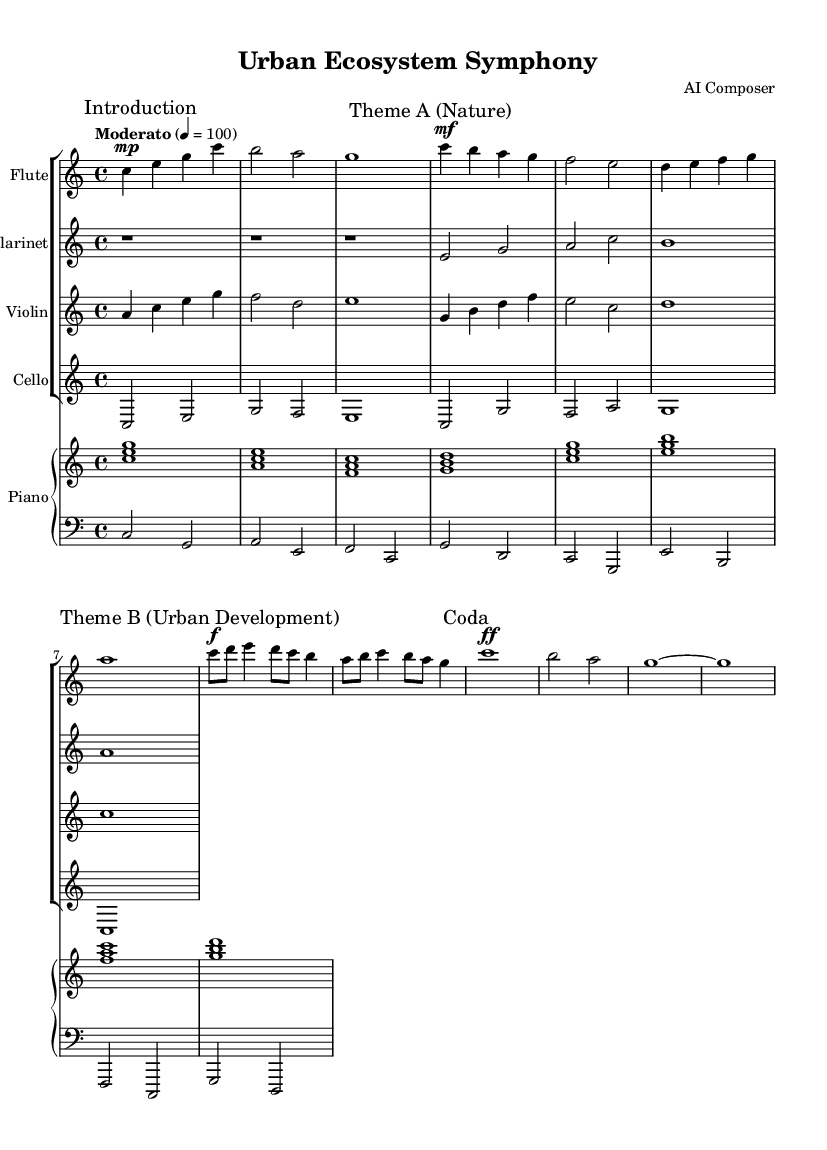What is the key signature of this music? The key signature is indicated at the beginning of the score. In this case, it is C major, which has no sharps or flats.
Answer: C major What is the time signature of this piece? The time signature can be found right after the key signature at the beginning. Here, it is written as 4/4, meaning there are four beats in each measure.
Answer: 4/4 What is the tempo marking for this composition? The tempo marking is also indicated at the beginning of the score. It states "Moderato" with a metronome marking of 100 beats per minute.
Answer: Moderato How many themes are present in this piece? The score explicitly labels different sections of the music: "Theme A" (Nature) and "Theme B" (Urban Development), which indicates there are two distinct themes present.
Answer: 2 What is the dynamic marking for Theme B? The dynamic marking for Theme B is indicated as "forte" (f), which suggests the music should be played loudly. This is found at the start of Theme B.
Answer: forte What instruments are featured in the composition? The score lists several instruments at the beginning. The featured instruments are Flute, Clarinet, Violin, Cello, and Piano. These are also noted in their respective staves.
Answer: Flute, Clarinet, Violin, Cello, Piano What is the purpose of the Coda section in this piece? The Coda indicates the concluding passage of the composition, bringing closure to the music. It contains distinct musical elements as indicated by the "Coda" marking. This section serves to summarize the themes explored.
Answer: Conclusion 